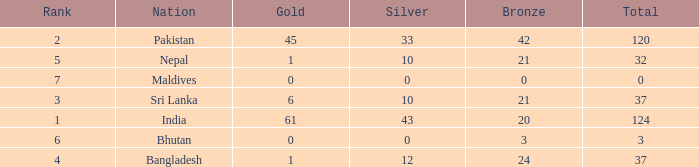How much Silver has a Rank of 7? 1.0. 